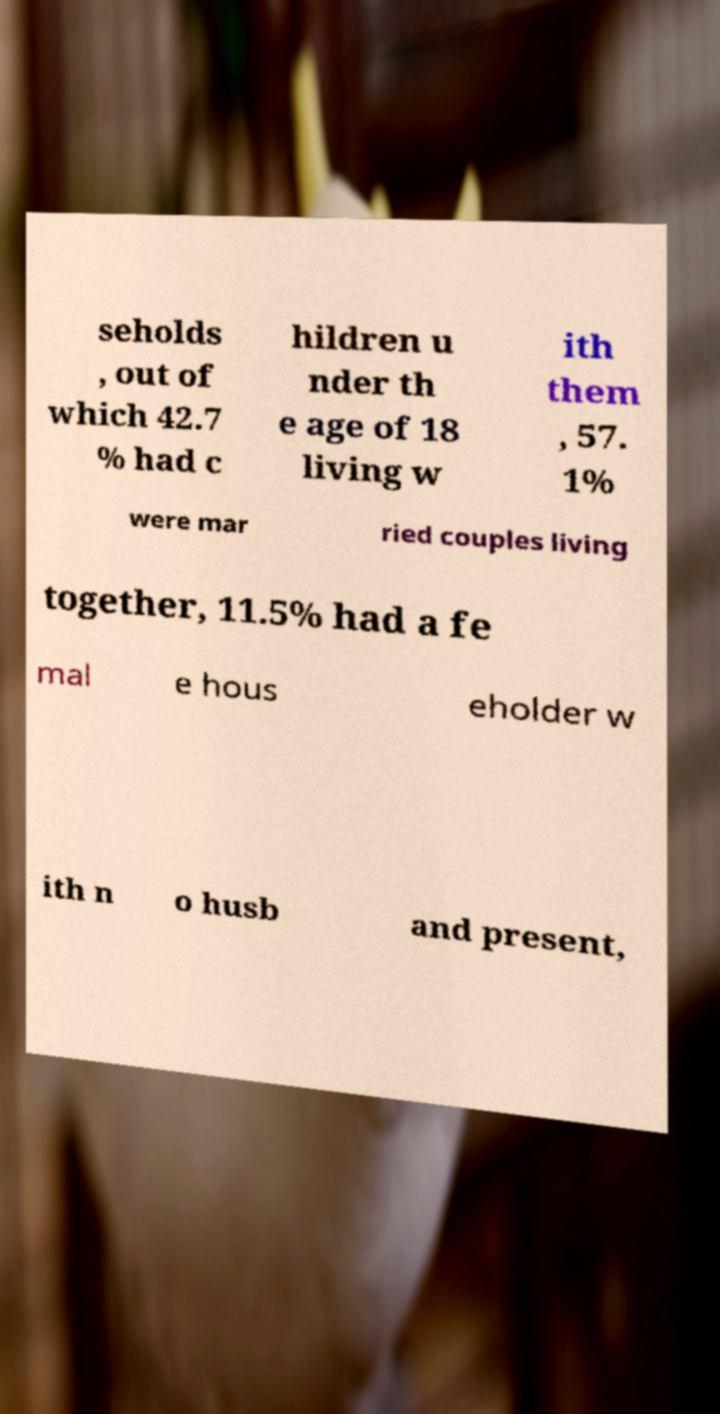What messages or text are displayed in this image? I need them in a readable, typed format. seholds , out of which 42.7 % had c hildren u nder th e age of 18 living w ith them , 57. 1% were mar ried couples living together, 11.5% had a fe mal e hous eholder w ith n o husb and present, 